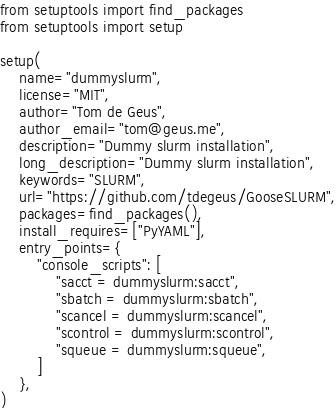<code> <loc_0><loc_0><loc_500><loc_500><_Python_>from setuptools import find_packages
from setuptools import setup

setup(
    name="dummyslurm",
    license="MIT",
    author="Tom de Geus",
    author_email="tom@geus.me",
    description="Dummy slurm installation",
    long_description="Dummy slurm installation",
    keywords="SLURM",
    url="https://github.com/tdegeus/GooseSLURM",
    packages=find_packages(),
    install_requires=["PyYAML"],
    entry_points={
        "console_scripts": [
            "sacct = dummyslurm:sacct",
            "sbatch = dummyslurm:sbatch",
            "scancel = dummyslurm:scancel",
            "scontrol = dummyslurm:scontrol",
            "squeue = dummyslurm:squeue",
        ]
    },
)
</code> 